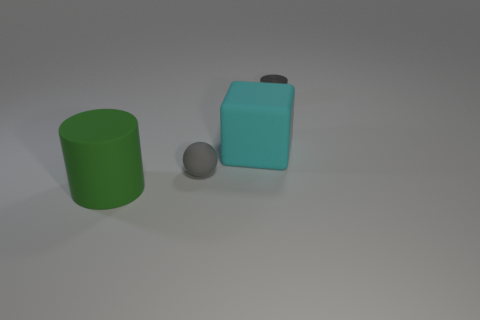What objects can be seen in the image? The image depicts three objects: a green cylinder, a cyan rectangular cuboid, and a grey sphere. What textures do the objects have? The objects appear to have a smooth, matte texture, which suggests they might be made from a plastic or metallic material with a non-reflective finish. 